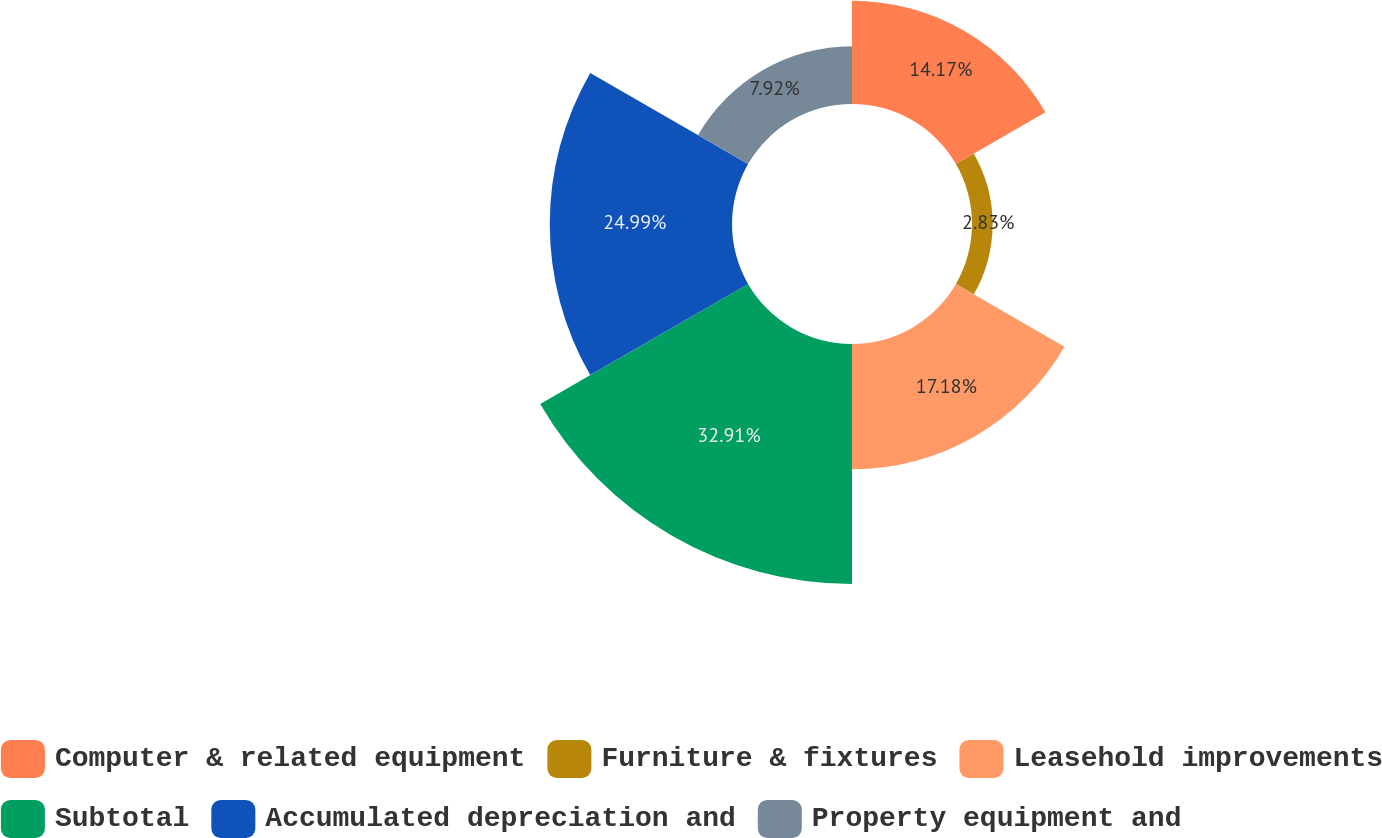<chart> <loc_0><loc_0><loc_500><loc_500><pie_chart><fcel>Computer & related equipment<fcel>Furniture & fixtures<fcel>Leasehold improvements<fcel>Subtotal<fcel>Accumulated depreciation and<fcel>Property equipment and<nl><fcel>14.17%<fcel>2.83%<fcel>17.18%<fcel>32.91%<fcel>24.99%<fcel>7.92%<nl></chart> 